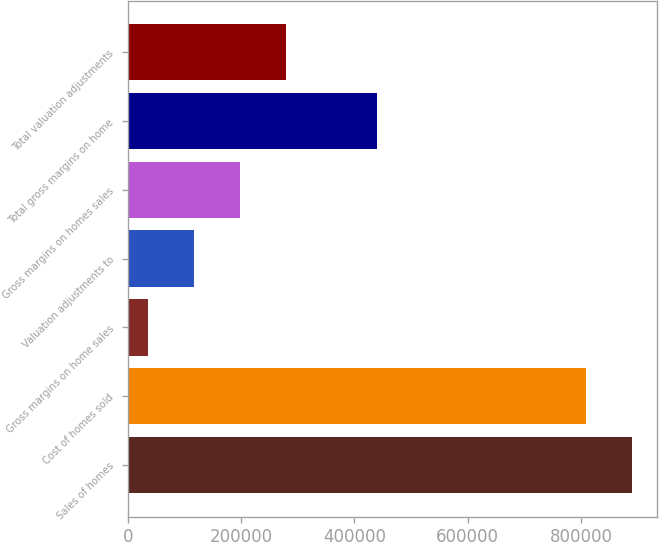Convert chart to OTSL. <chart><loc_0><loc_0><loc_500><loc_500><bar_chart><fcel>Sales of homes<fcel>Cost of homes sold<fcel>Gross margins on home sales<fcel>Valuation adjustments to<fcel>Gross margins on homes sales<fcel>Total gross margins on home<fcel>Total valuation adjustments<nl><fcel>889381<fcel>808528<fcel>36161<fcel>117014<fcel>197867<fcel>440425<fcel>278719<nl></chart> 